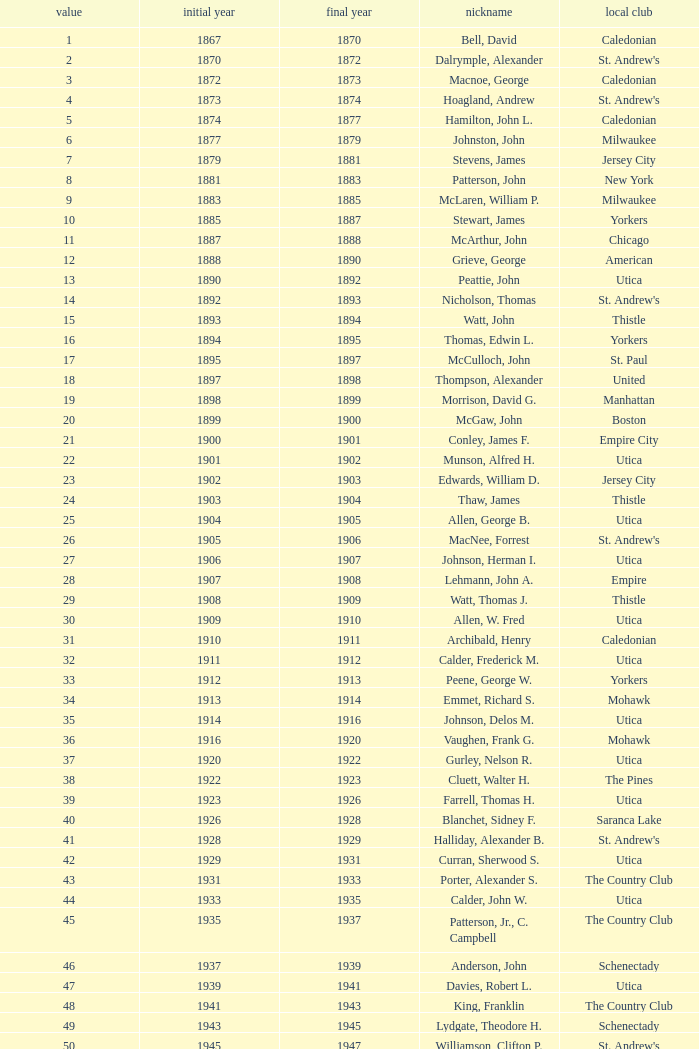Which Number has a Name of cooper, c. kenneth, and a Year End larger than 1984? None. 